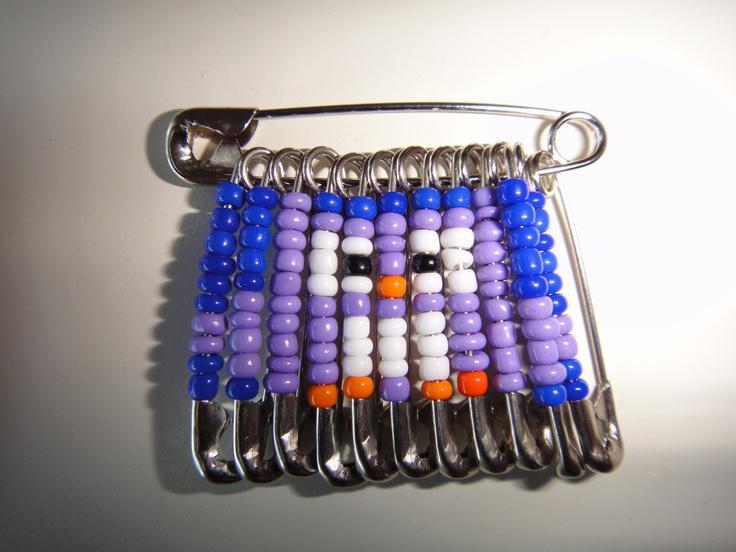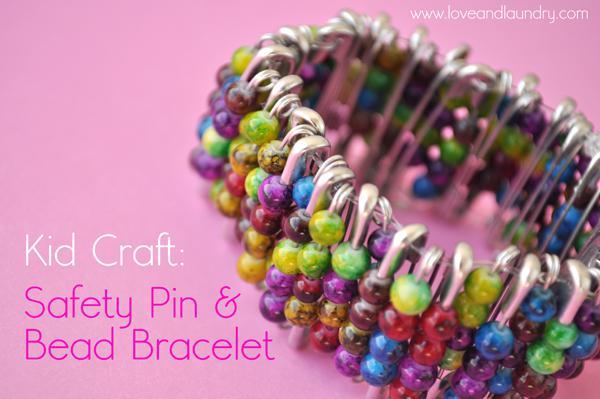The first image is the image on the left, the second image is the image on the right. Assess this claim about the two images: "An image shows only a bracelet made of safety pins strung with multicolored beads.". Correct or not? Answer yes or no. Yes. 